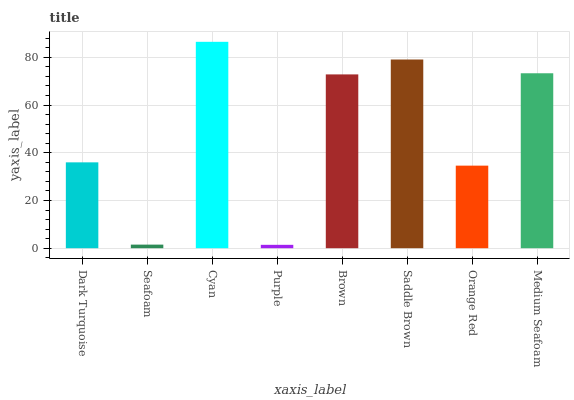Is Purple the minimum?
Answer yes or no. Yes. Is Cyan the maximum?
Answer yes or no. Yes. Is Seafoam the minimum?
Answer yes or no. No. Is Seafoam the maximum?
Answer yes or no. No. Is Dark Turquoise greater than Seafoam?
Answer yes or no. Yes. Is Seafoam less than Dark Turquoise?
Answer yes or no. Yes. Is Seafoam greater than Dark Turquoise?
Answer yes or no. No. Is Dark Turquoise less than Seafoam?
Answer yes or no. No. Is Brown the high median?
Answer yes or no. Yes. Is Dark Turquoise the low median?
Answer yes or no. Yes. Is Seafoam the high median?
Answer yes or no. No. Is Purple the low median?
Answer yes or no. No. 